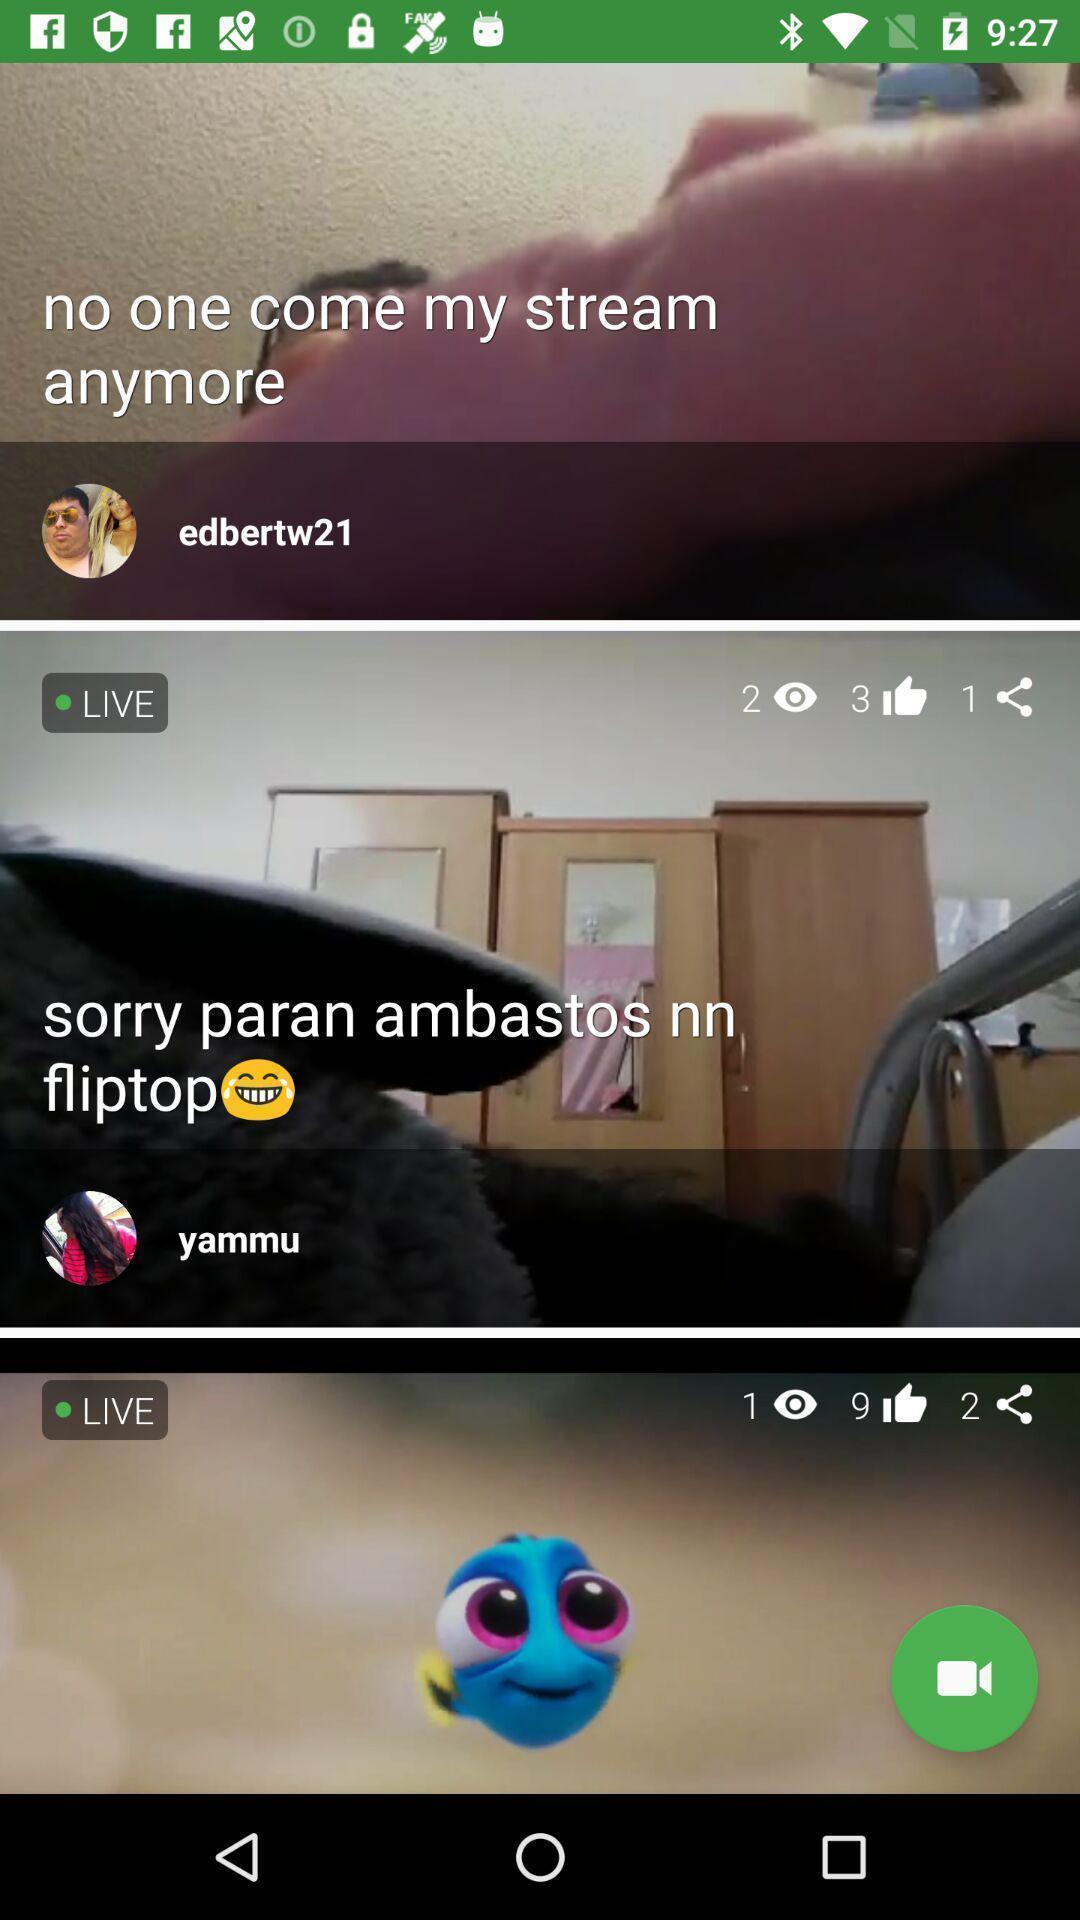What details can you identify in this image? Page displaying various live shows in live streaming app. 